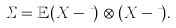<formula> <loc_0><loc_0><loc_500><loc_500>\Sigma = \mathbb { E } ( X - \mu ) \otimes ( X - \mu ) .</formula> 